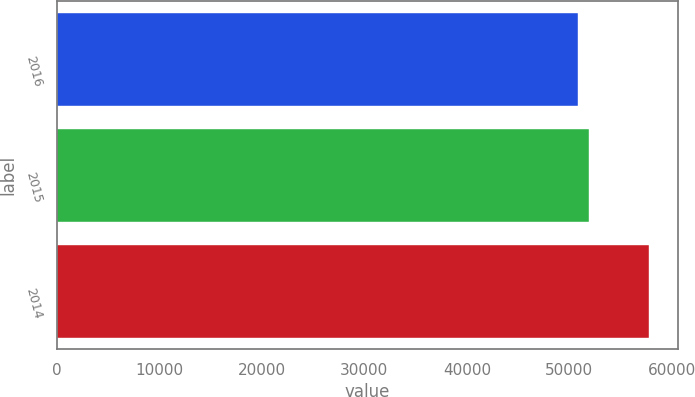<chart> <loc_0><loc_0><loc_500><loc_500><bar_chart><fcel>2016<fcel>2015<fcel>2014<nl><fcel>50823<fcel>51888<fcel>57719<nl></chart> 